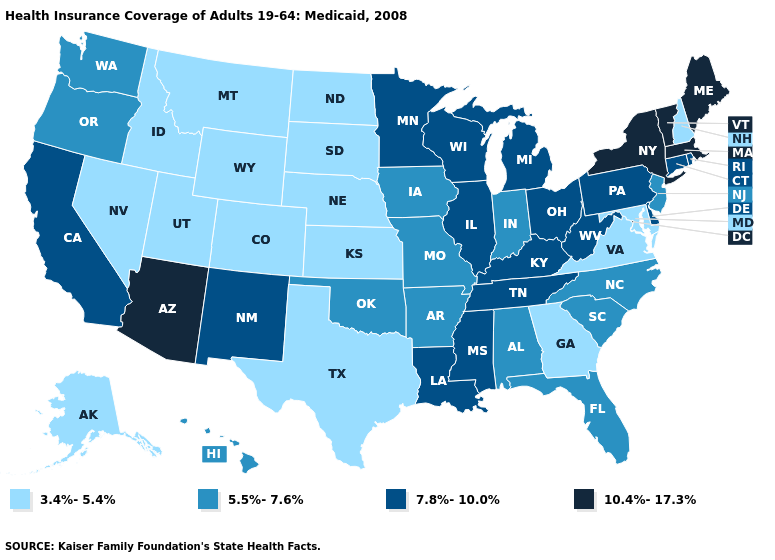Among the states that border Nevada , which have the lowest value?
Short answer required. Idaho, Utah. Does Michigan have the lowest value in the USA?
Short answer required. No. Does Arizona have the lowest value in the West?
Write a very short answer. No. What is the lowest value in the Northeast?
Answer briefly. 3.4%-5.4%. What is the highest value in the USA?
Answer briefly. 10.4%-17.3%. Is the legend a continuous bar?
Answer briefly. No. Does Maine have a higher value than New York?
Be succinct. No. Does the first symbol in the legend represent the smallest category?
Quick response, please. Yes. Name the states that have a value in the range 5.5%-7.6%?
Keep it brief. Alabama, Arkansas, Florida, Hawaii, Indiana, Iowa, Missouri, New Jersey, North Carolina, Oklahoma, Oregon, South Carolina, Washington. What is the value of Ohio?
Quick response, please. 7.8%-10.0%. Does Idaho have the lowest value in the USA?
Quick response, please. Yes. What is the value of New Mexico?
Answer briefly. 7.8%-10.0%. What is the value of New Jersey?
Quick response, please. 5.5%-7.6%. Name the states that have a value in the range 7.8%-10.0%?
Answer briefly. California, Connecticut, Delaware, Illinois, Kentucky, Louisiana, Michigan, Minnesota, Mississippi, New Mexico, Ohio, Pennsylvania, Rhode Island, Tennessee, West Virginia, Wisconsin. Does New Hampshire have the lowest value in the USA?
Keep it brief. Yes. 